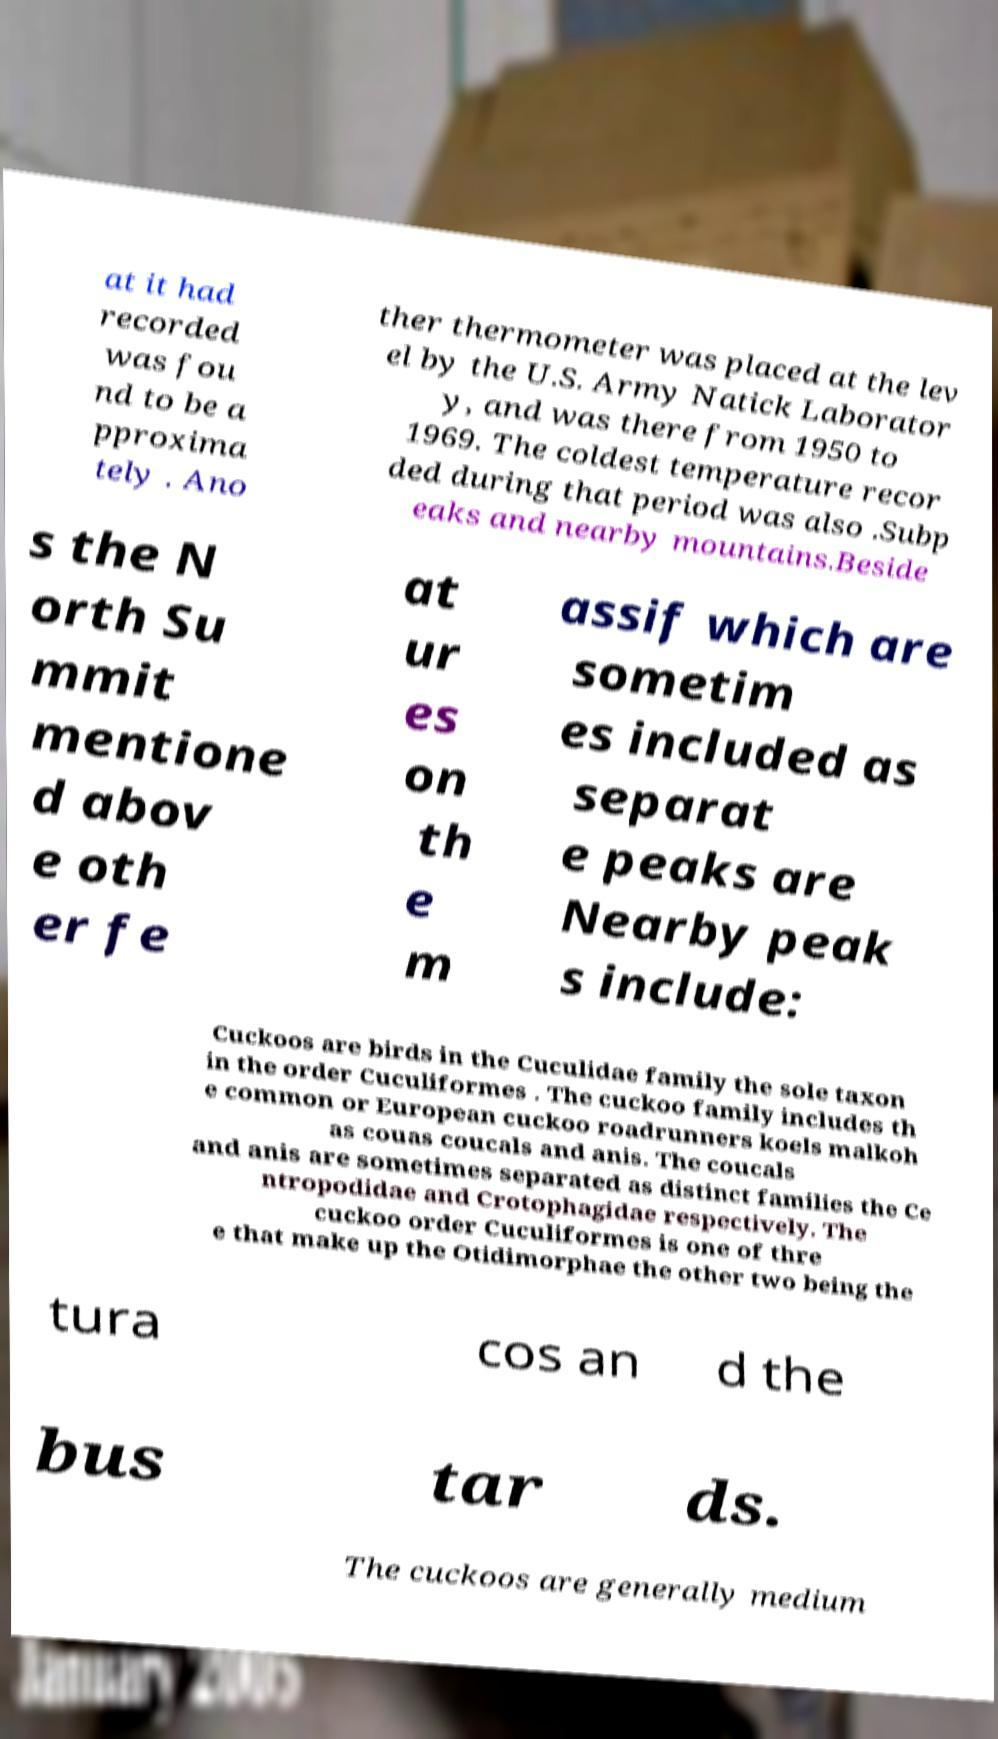Could you assist in decoding the text presented in this image and type it out clearly? at it had recorded was fou nd to be a pproxima tely . Ano ther thermometer was placed at the lev el by the U.S. Army Natick Laborator y, and was there from 1950 to 1969. The coldest temperature recor ded during that period was also .Subp eaks and nearby mountains.Beside s the N orth Su mmit mentione d abov e oth er fe at ur es on th e m assif which are sometim es included as separat e peaks are Nearby peak s include: Cuckoos are birds in the Cuculidae family the sole taxon in the order Cuculiformes . The cuckoo family includes th e common or European cuckoo roadrunners koels malkoh as couas coucals and anis. The coucals and anis are sometimes separated as distinct families the Ce ntropodidae and Crotophagidae respectively. The cuckoo order Cuculiformes is one of thre e that make up the Otidimorphae the other two being the tura cos an d the bus tar ds. The cuckoos are generally medium 